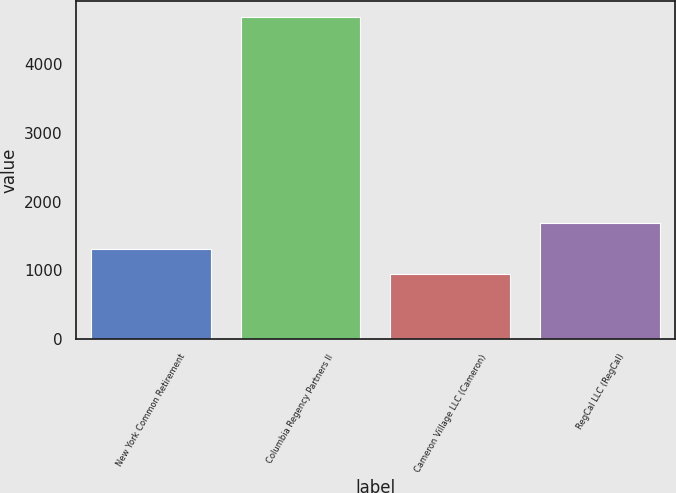Convert chart to OTSL. <chart><loc_0><loc_0><loc_500><loc_500><bar_chart><fcel>New York Common Retirement<fcel>Columbia Regency Partners II<fcel>Cameron Village LLC (Cameron)<fcel>RegCal LLC (RegCal)<nl><fcel>1316<fcel>4673<fcel>943<fcel>1689<nl></chart> 